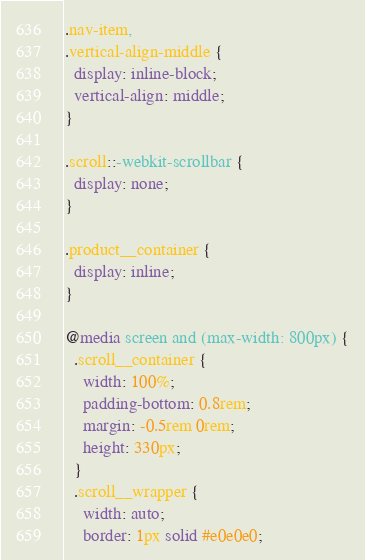Convert code to text. <code><loc_0><loc_0><loc_500><loc_500><_CSS_>
.nav-item,
.vertical-align-middle {
  display: inline-block;
  vertical-align: middle;
}

.scroll::-webkit-scrollbar {
  display: none;
}

.product__container {
  display: inline;
}

@media screen and (max-width: 800px) {
  .scroll__container {
    width: 100%;
    padding-bottom: 0.8rem;
    margin: -0.5rem 0rem;
    height: 330px;
  }
  .scroll__wrapper {
    width: auto;
    border: 1px solid #e0e0e0;</code> 